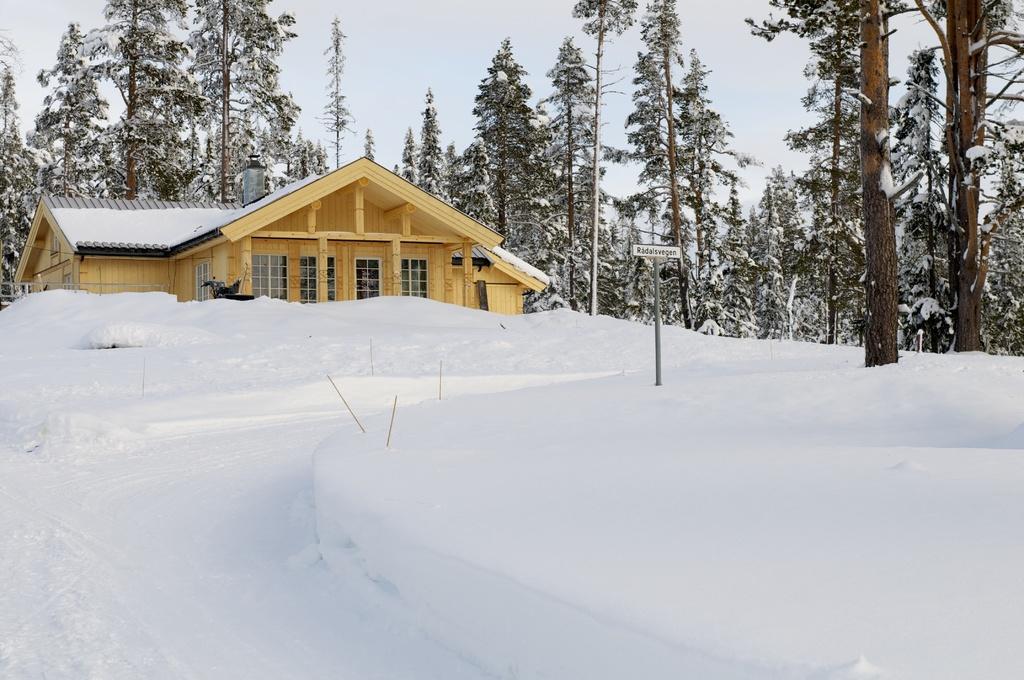How would you summarize this image in a sentence or two? In this image there is a wooden house in the middle. In front of the house there is full of snow. In the background there are trees which are covered by the snow. At the top there is the sky. 